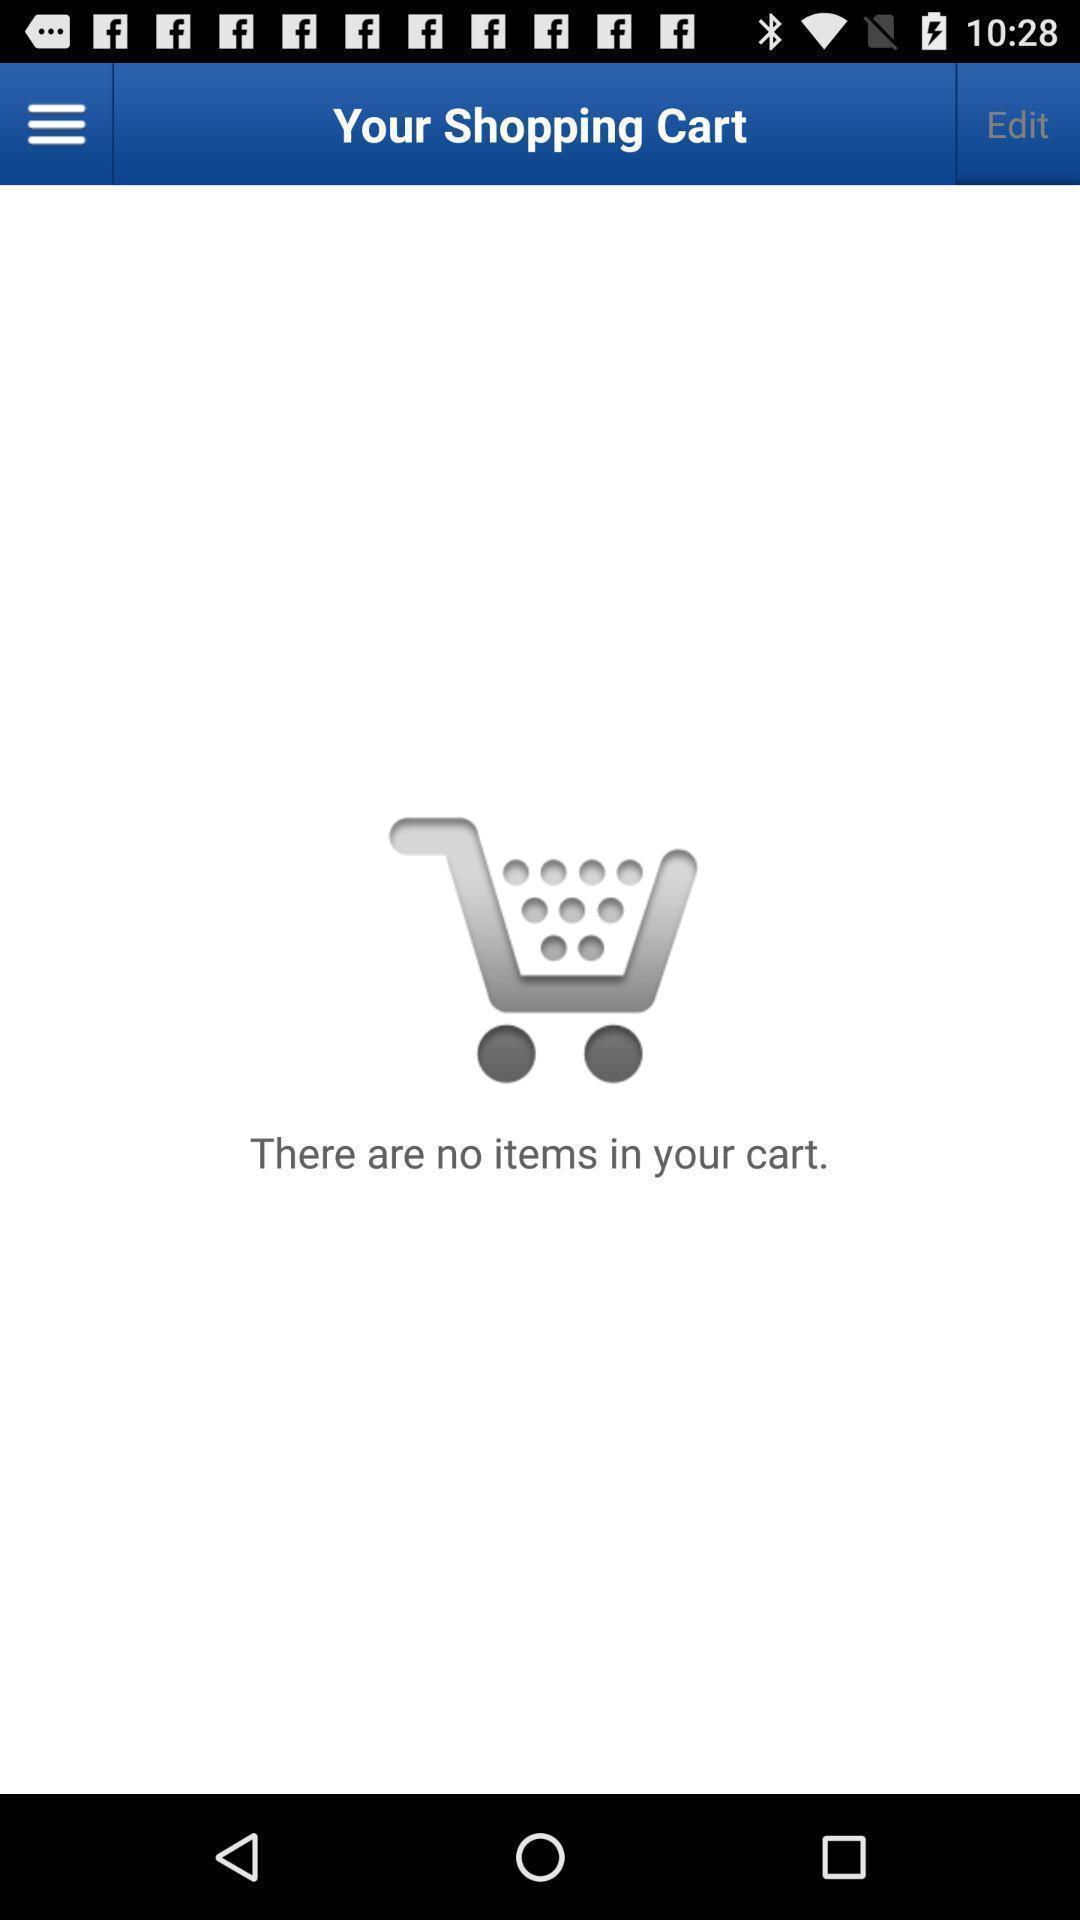What can you discern from this picture? Screen shows no items in a shopping cart. 